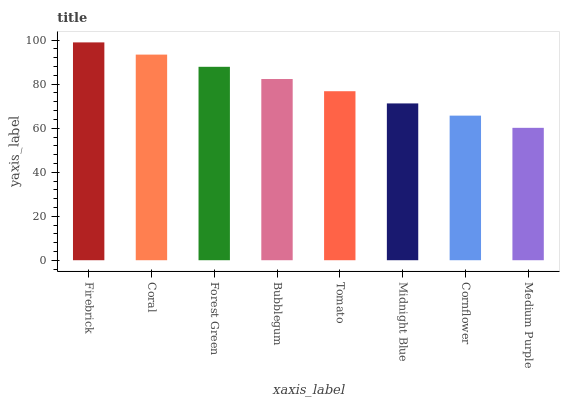Is Medium Purple the minimum?
Answer yes or no. Yes. Is Firebrick the maximum?
Answer yes or no. Yes. Is Coral the minimum?
Answer yes or no. No. Is Coral the maximum?
Answer yes or no. No. Is Firebrick greater than Coral?
Answer yes or no. Yes. Is Coral less than Firebrick?
Answer yes or no. Yes. Is Coral greater than Firebrick?
Answer yes or no. No. Is Firebrick less than Coral?
Answer yes or no. No. Is Bubblegum the high median?
Answer yes or no. Yes. Is Tomato the low median?
Answer yes or no. Yes. Is Firebrick the high median?
Answer yes or no. No. Is Coral the low median?
Answer yes or no. No. 